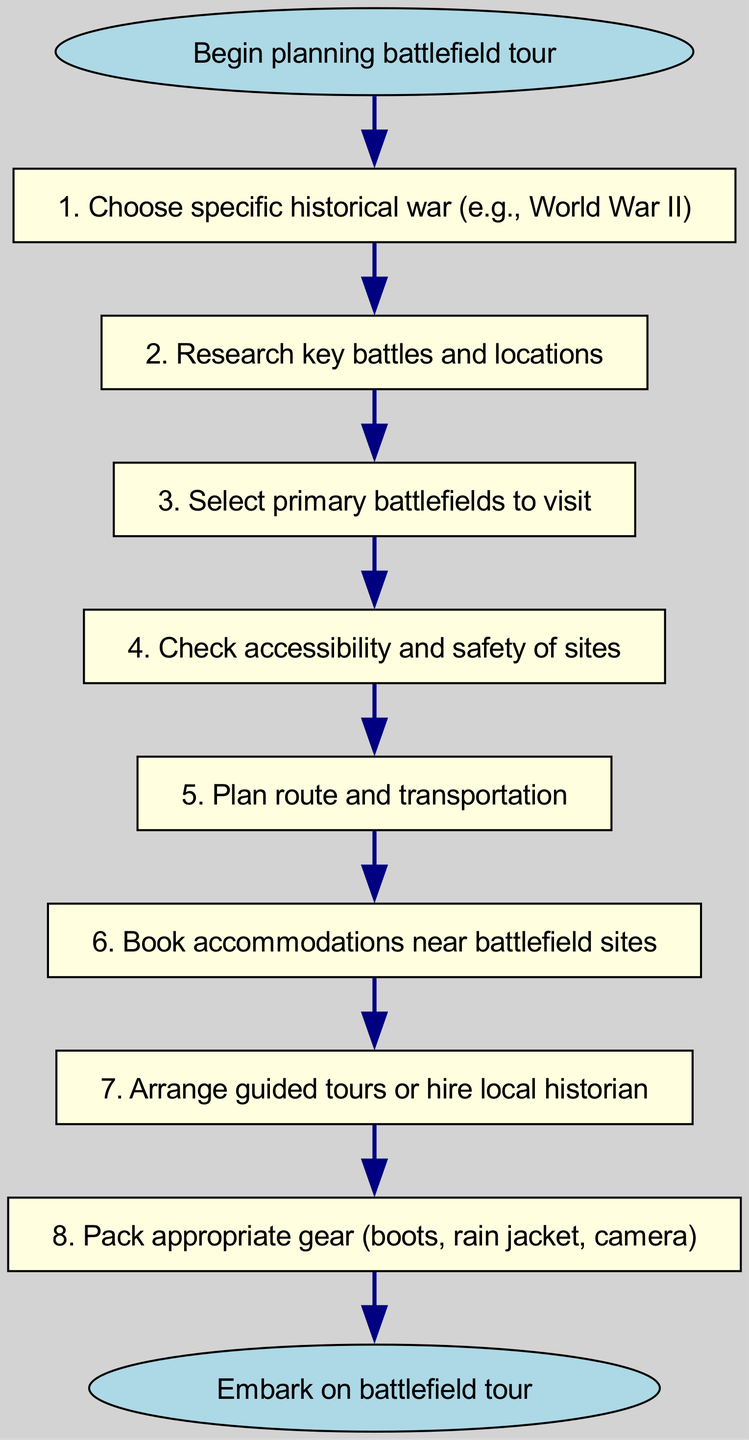What is the first step in planning a battlefield tour? The diagram indicates that the first step is to choose a specific historical war, which is represented by the second node after the start.
Answer: Choose specific historical war (e.g., World War II) How many total steps are in the procedure? By counting the nodes from the start to the end, there are eight steps involved in the procedure before reaching the end of the flowchart.
Answer: Eight What follows after researching key battles and locations? According to the connections in the diagram, selecting primary battlefields to visit directly follows the step of researching key battles and locations.
Answer: Select primary battlefields to visit Which step confirms the safety of sites? The step that focuses on checking the accessibility and safety of sites comes directly after selecting primary battlefields to visit, indicating its purpose in the process.
Answer: Check accessibility and safety of sites What is the last action before embarking on the battlefield tour? The last step before embarking on the tour is to pack appropriate gear, which is the final action indicated in the flowchart.
Answer: Pack appropriate gear (boots, rain jacket, camera) After selecting primary battlefields, what is the next action? The diagram shows a clear connection whereby checking the accessibility and safety of sites is the immediate action taken after selecting the primary battlefields to visit.
Answer: Check accessibility and safety of sites How many connections are there in the diagram? If we count the connections shown in the diagram, we get a total of eight connections that represent the transitions between each step.
Answer: Eight What is the role of guided tours or hiring a local historian in the planning process? The step of arranging guided tours or hiring a local historian is part of the process after booking accommodations, emphasizing the importance of expert guidance in the battlefield experience.
Answer: Arrange guided tours or hire local historian What is the shape of the final node in the diagram? The final node in the diagram, which represents embarking on the battlefield tour, is shaped as an oval, distinguishing it from the rectangular nodes that represent prior steps.
Answer: Oval 